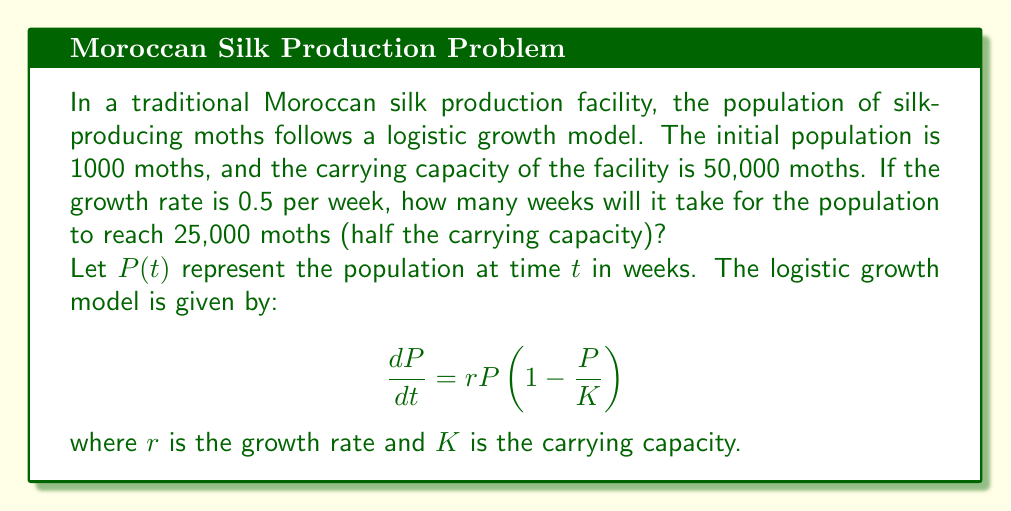Help me with this question. To solve this problem, we'll use the analytical solution of the logistic growth model:

$$P(t) = \frac{K}{1 + (\frac{K}{P_0} - 1)e^{-rt}}$$

Where:
$K = 50,000$ (carrying capacity)
$P_0 = 1,000$ (initial population)
$r = 0.5$ (growth rate per week)

We want to find $t$ when $P(t) = 25,000$ (half the carrying capacity).

Step 1: Substitute the known values into the equation:

$$25,000 = \frac{50,000}{1 + (\frac{50,000}{1,000} - 1)e^{-0.5t}}$$

Step 2: Simplify:

$$25,000 = \frac{50,000}{1 + 49e^{-0.5t}}$$

Step 3: Multiply both sides by the denominator:

$$25,000(1 + 49e^{-0.5t}) = 50,000$$

Step 4: Expand:

$$25,000 + 1,225,000e^{-0.5t} = 50,000$$

Step 5: Subtract 25,000 from both sides:

$$1,225,000e^{-0.5t} = 25,000$$

Step 6: Divide both sides by 1,225,000:

$$e^{-0.5t} = \frac{1}{49}$$

Step 7: Take the natural logarithm of both sides:

$$-0.5t = \ln(\frac{1}{49})$$

Step 8: Solve for $t$:

$$t = -\frac{2\ln(\frac{1}{49})}{0.5} = 2\ln(49) \approx 7.81$$

Therefore, it will take approximately 7.81 weeks for the population to reach 25,000 moths.
Answer: Approximately 7.81 weeks 